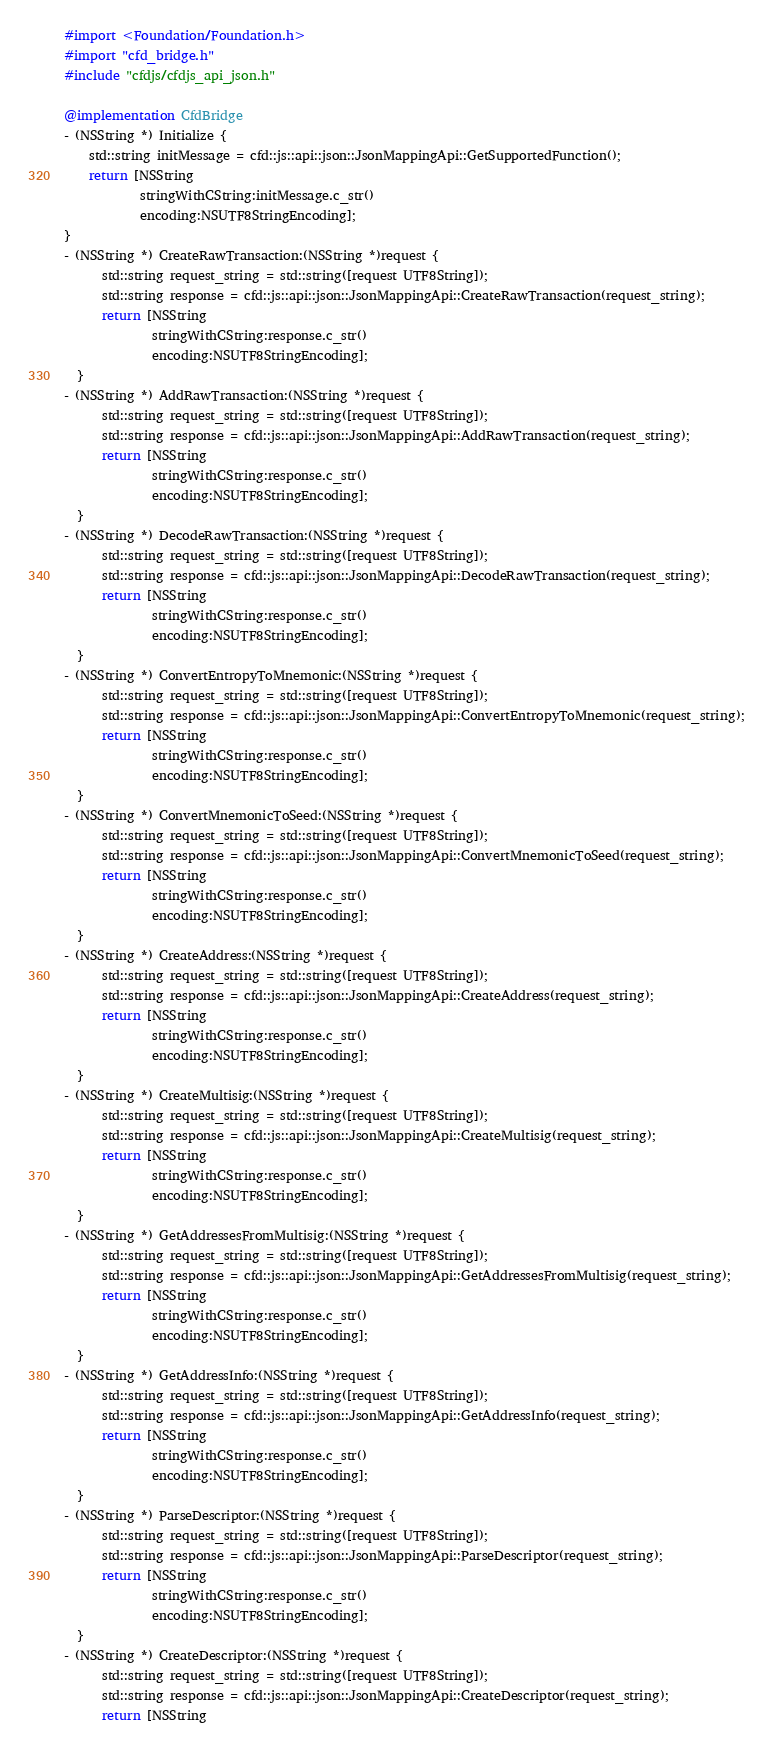Convert code to text. <code><loc_0><loc_0><loc_500><loc_500><_ObjectiveC_>#import <Foundation/Foundation.h>
#import "cfd_bridge.h"
#include "cfdjs/cfdjs_api_json.h"

@implementation CfdBridge
- (NSString *) Initialize {
    std::string initMessage = cfd::js::api::json::JsonMappingApi::GetSupportedFunction();
    return [NSString
            stringWithCString:initMessage.c_str()
            encoding:NSUTF8StringEncoding];
}
- (NSString *) CreateRawTransaction:(NSString *)request {
      std::string request_string = std::string([request UTF8String]);
      std::string response = cfd::js::api::json::JsonMappingApi::CreateRawTransaction(request_string);
      return [NSString
              stringWithCString:response.c_str()
              encoding:NSUTF8StringEncoding];
  }
- (NSString *) AddRawTransaction:(NSString *)request {
      std::string request_string = std::string([request UTF8String]);
      std::string response = cfd::js::api::json::JsonMappingApi::AddRawTransaction(request_string);
      return [NSString
              stringWithCString:response.c_str()
              encoding:NSUTF8StringEncoding];
  }
- (NSString *) DecodeRawTransaction:(NSString *)request {
      std::string request_string = std::string([request UTF8String]);
      std::string response = cfd::js::api::json::JsonMappingApi::DecodeRawTransaction(request_string);
      return [NSString
              stringWithCString:response.c_str()
              encoding:NSUTF8StringEncoding];
  }
- (NSString *) ConvertEntropyToMnemonic:(NSString *)request {
      std::string request_string = std::string([request UTF8String]);
      std::string response = cfd::js::api::json::JsonMappingApi::ConvertEntropyToMnemonic(request_string);
      return [NSString
              stringWithCString:response.c_str()
              encoding:NSUTF8StringEncoding];
  }
- (NSString *) ConvertMnemonicToSeed:(NSString *)request {
      std::string request_string = std::string([request UTF8String]);
      std::string response = cfd::js::api::json::JsonMappingApi::ConvertMnemonicToSeed(request_string);
      return [NSString
              stringWithCString:response.c_str()
              encoding:NSUTF8StringEncoding];
  }
- (NSString *) CreateAddress:(NSString *)request {
      std::string request_string = std::string([request UTF8String]);
      std::string response = cfd::js::api::json::JsonMappingApi::CreateAddress(request_string);
      return [NSString
              stringWithCString:response.c_str()
              encoding:NSUTF8StringEncoding];
  }
- (NSString *) CreateMultisig:(NSString *)request {
      std::string request_string = std::string([request UTF8String]);
      std::string response = cfd::js::api::json::JsonMappingApi::CreateMultisig(request_string);
      return [NSString
              stringWithCString:response.c_str()
              encoding:NSUTF8StringEncoding];
  }
- (NSString *) GetAddressesFromMultisig:(NSString *)request {
      std::string request_string = std::string([request UTF8String]);
      std::string response = cfd::js::api::json::JsonMappingApi::GetAddressesFromMultisig(request_string);
      return [NSString
              stringWithCString:response.c_str()
              encoding:NSUTF8StringEncoding];
  }
- (NSString *) GetAddressInfo:(NSString *)request {
      std::string request_string = std::string([request UTF8String]);
      std::string response = cfd::js::api::json::JsonMappingApi::GetAddressInfo(request_string);
      return [NSString
              stringWithCString:response.c_str()
              encoding:NSUTF8StringEncoding];
  }
- (NSString *) ParseDescriptor:(NSString *)request {
      std::string request_string = std::string([request UTF8String]);
      std::string response = cfd::js::api::json::JsonMappingApi::ParseDescriptor(request_string);
      return [NSString
              stringWithCString:response.c_str()
              encoding:NSUTF8StringEncoding];
  }
- (NSString *) CreateDescriptor:(NSString *)request {
      std::string request_string = std::string([request UTF8String]);
      std::string response = cfd::js::api::json::JsonMappingApi::CreateDescriptor(request_string);
      return [NSString</code> 